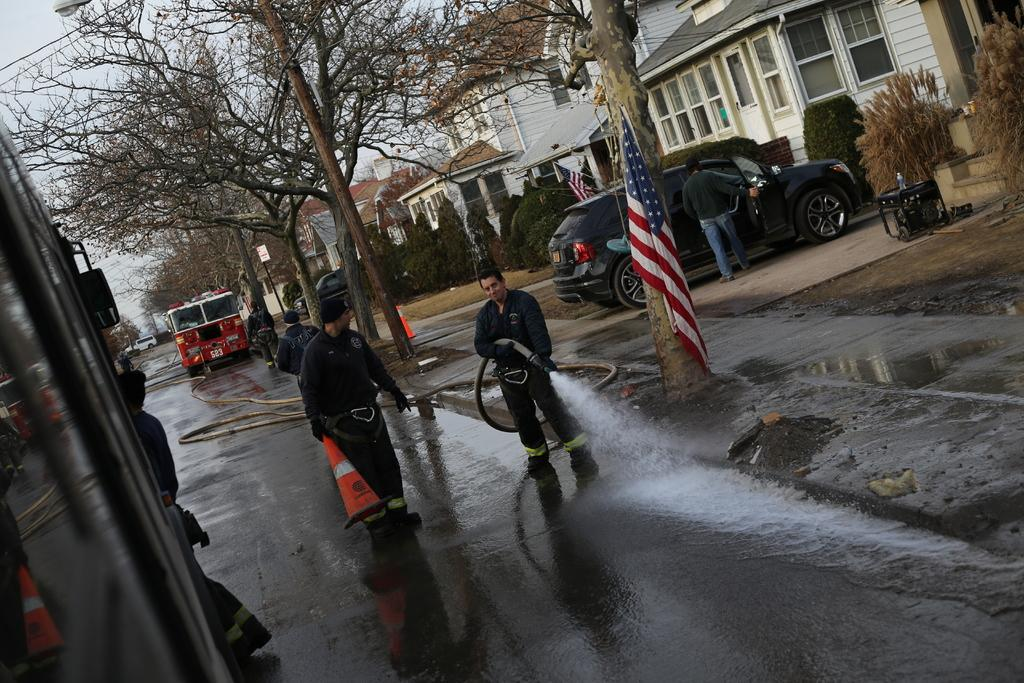What types of objects can be seen in the image? There are vehicles and people in the image. What are some people doing in the image? Some people are holding objects in the image. What other elements can be seen in the image? There are trees, flags, and plants in the image. What can be seen in the background of the image? The sky is visible in the background of the image. What type of lace can be seen in the image? There is no lace present in the image. 